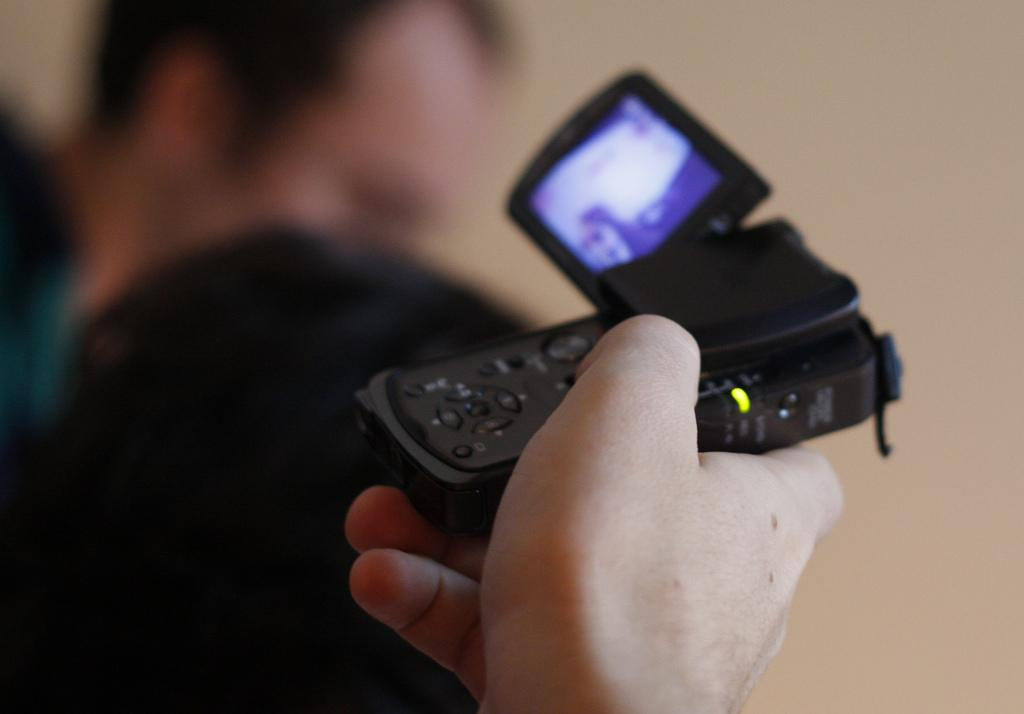What is the man in the image holding? The man is holding a camera in the image. Can you describe the camera? The camera is black. What can be seen in the background of the image? There is a wall in the background of the image. Where is the second man located in the image? The second man is on the left side of the image. How is the background of the image depicted? The background is blurred. Why is the man on the left side of the image crying in the image? There is no indication in the image that the man on the left side is crying; he is simply standing there. 